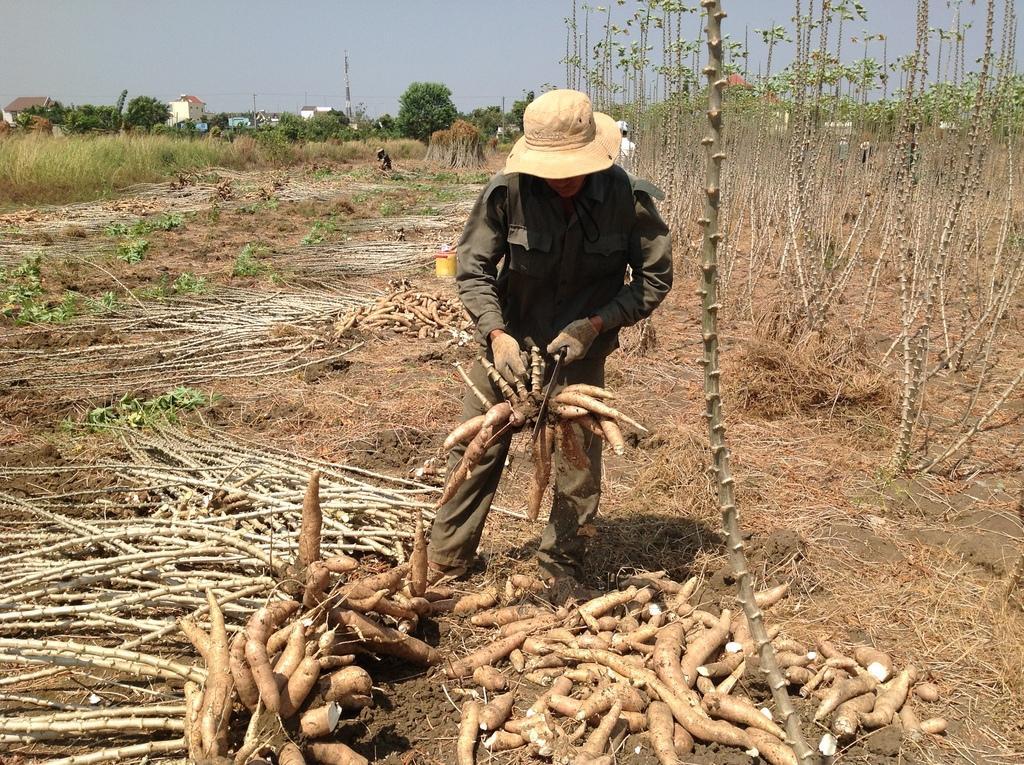Can you describe this image briefly? In this image in the center there is one person standing and he is holding sweet potatoes, and at the bottom there are some sweet potatoes and sand and there are some plants. In the background there are some houses, poles, trees and at the top there is sky. 